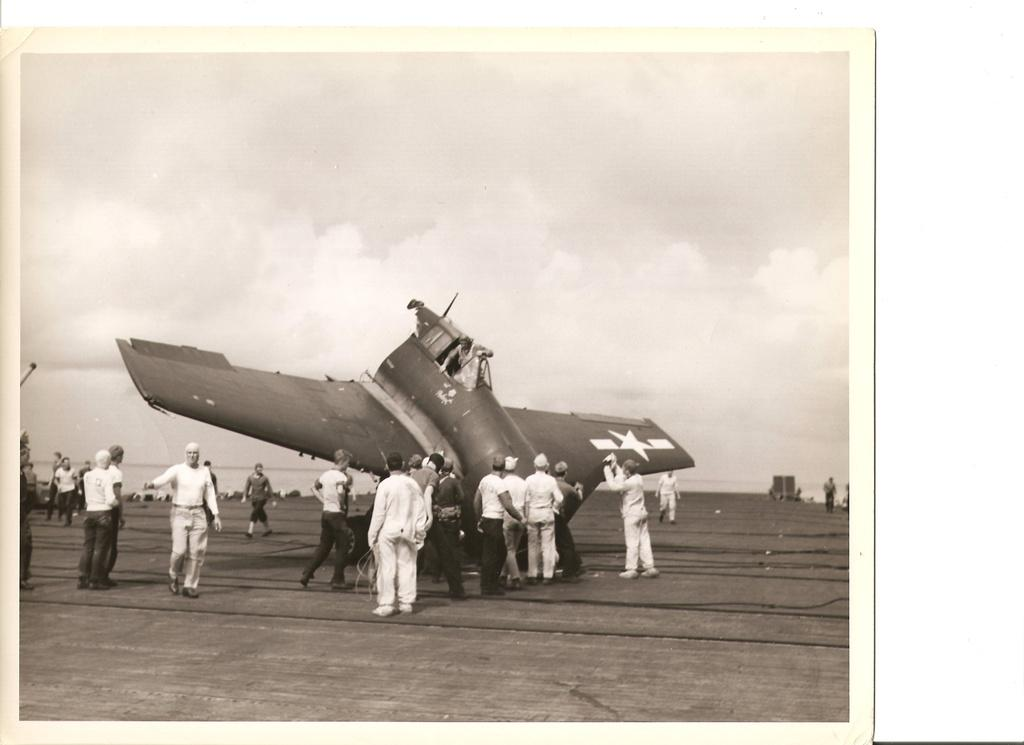What is the color scheme of the image? The image is in black and white. What can be seen in the image besides the color scheme? There are people and an aircraft on the road in the image. What is visible at the top of the image? The sky is visible at the top of the image. What type of apple is being used to fix the aircraft in the image? There is no apple present in the image, and the aircraft is not being fixed. 